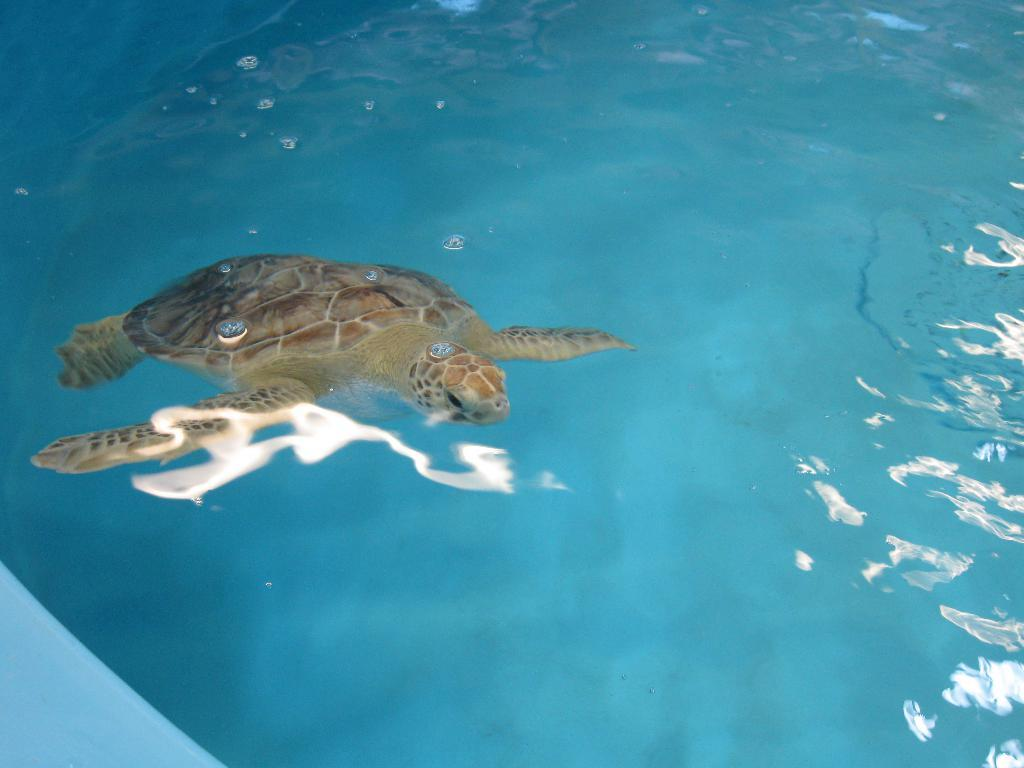What type of animal is in the water in the image? There is a turtle in the water in the image. What type of voice can be heard coming from the turtle in the image? Turtles do not have the ability to produce a voice, so there is no voice coming from the turtle in the image. 